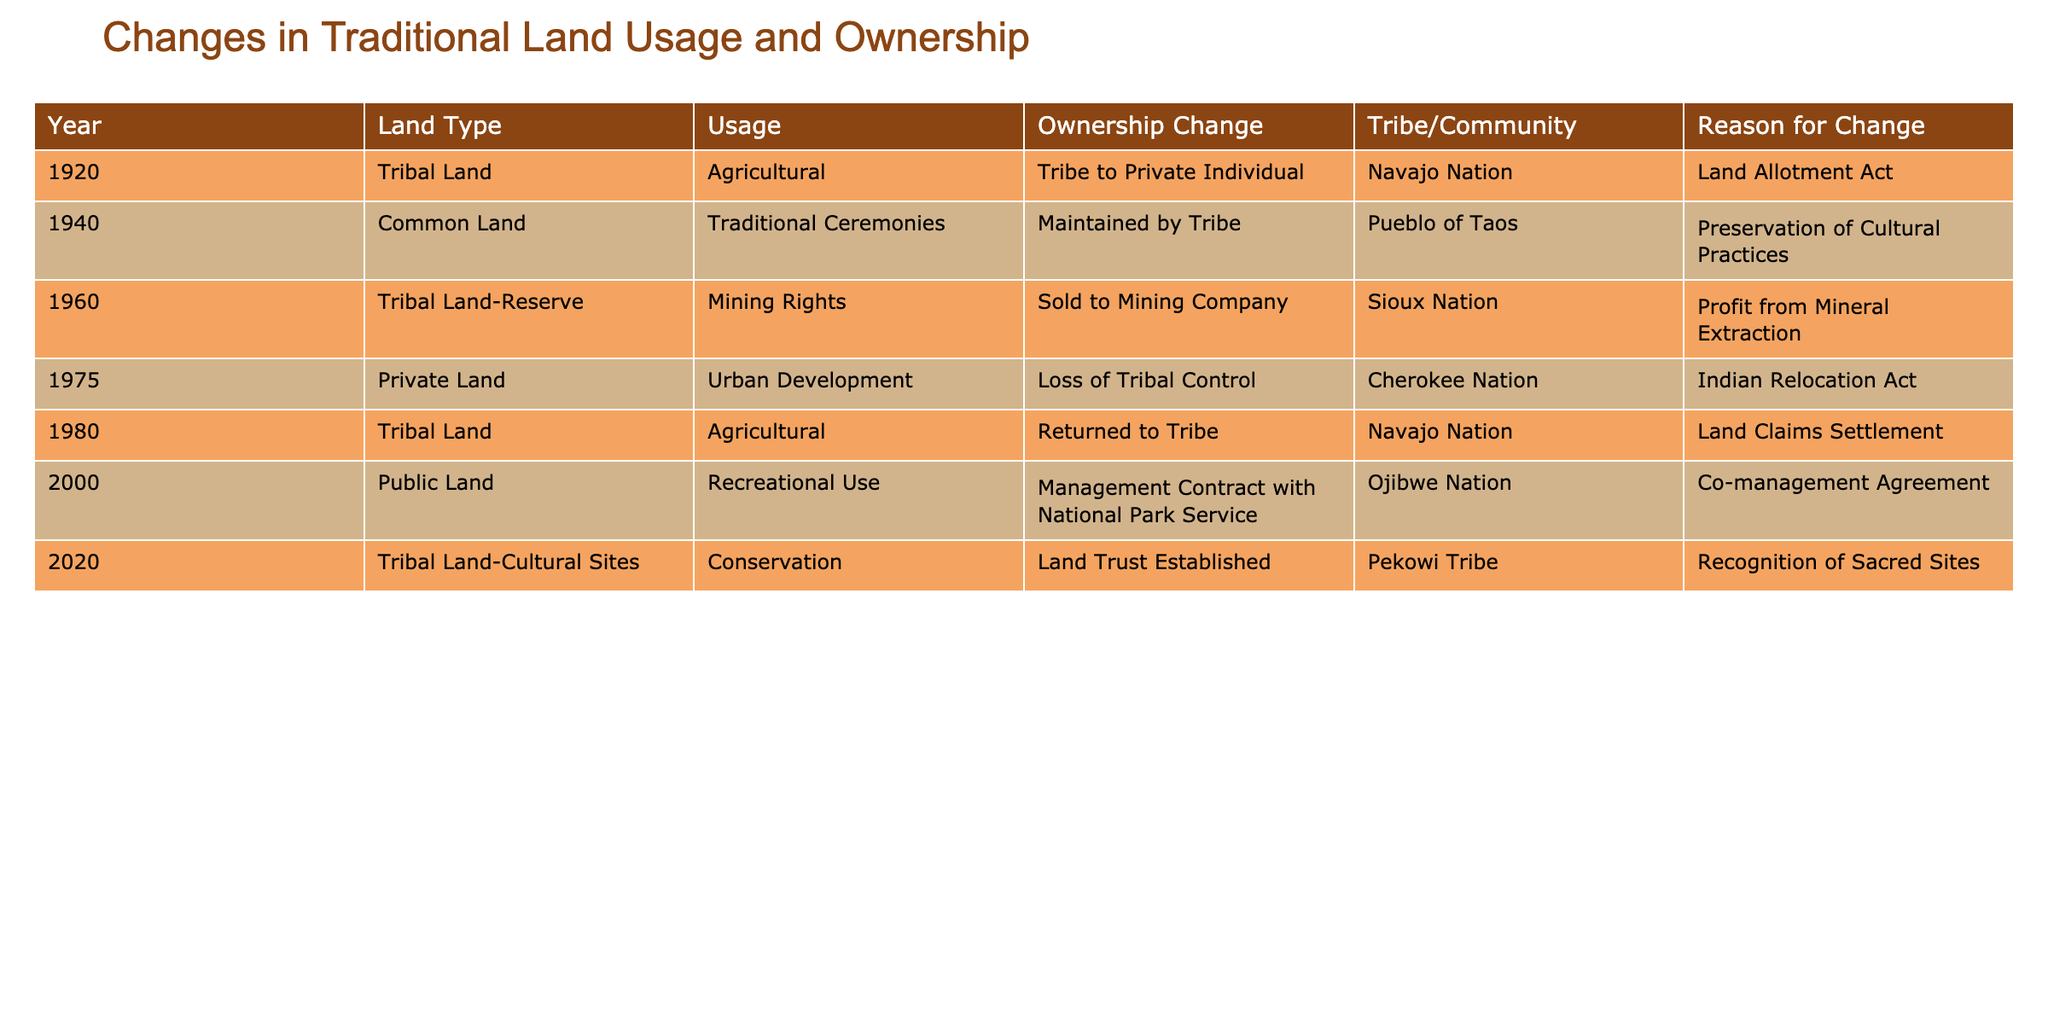What is the usage type for the land in 1960? The table states that in 1960, the usage type for the land is "Mining Rights." This is found by locating the year 1960 in the table and checking the corresponding "Usage" column.
Answer: Mining Rights Did the Navajo Nation regain control of the land in 1980? The table indicates that in 1980, the ownership change was "Returned to Tribe" for the Navajo Nation. Therefore, yes, they did regain control.
Answer: Yes How many times did land switch ownership from a tribe to a private individual? By reviewing the "Ownership Change" column in the table, I see that land switched ownership from a tribe to a private individual only once, which was in 1920. Thus, the count is 1.
Answer: 1 What year did the Sioux Nation sell land to a mining company? Referring to the table, the Sioux Nation sold land to a mining company in 1960. I find this by looking for the Sioux Nation in the "Tribe/Community" column and checking the corresponding year.
Answer: 1960 Which tribe established a land trust for conservation in 2020? The table shows that in 2020, the Pekowi Tribe established a land trust for conservation. This is verified by checking the "Tribe/Community" column for the year 2020.
Answer: Pekowi Tribe What is the difference in the number of years between the first and last entry in the table? The first entry is from 1920 and the last entry is from 2020. The difference is calculated by subtracting 1920 from 2020, resulting in 100 years.
Answer: 100 Was there a change in land usage for the Pueblo of Taos from 1940 to 2020? The table shows that the Pueblo of Taos maintained usage for traditional ceremonies in 1940, while in 2020, conservation is listed for the Pekowi Tribe. So, this indicates that there was a change in land usage with a different tribe involved.
Answer: Yes How many different tribes are represented in the table? By reviewing the "Tribe/Community" column, we list the different tribes: Navajo Nation, Pueblo of Taos, Sioux Nation, Cherokee Nation, Ojibwe Nation, and Pekowi Tribe. This counts to a total of 6 different tribes.
Answer: 6 What was the reason for the land switch to private ownership for the Cherokee Nation in 1975? The table specifies that in 1975, the reason for the loss of tribal control for the Cherokee Nation was due to the Indian Relocation Act. This is found under the "Reason for Change" column corresponding to the Cherokee Nation.
Answer: Indian Relocation Act 